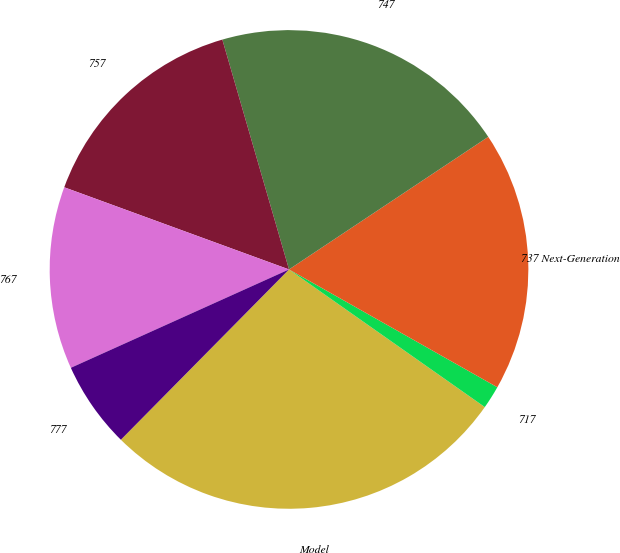Convert chart. <chart><loc_0><loc_0><loc_500><loc_500><pie_chart><fcel>Model<fcel>717<fcel>737 Next-Generation<fcel>747<fcel>757<fcel>767<fcel>777<nl><fcel>27.65%<fcel>1.56%<fcel>17.54%<fcel>20.15%<fcel>14.93%<fcel>12.32%<fcel>5.86%<nl></chart> 